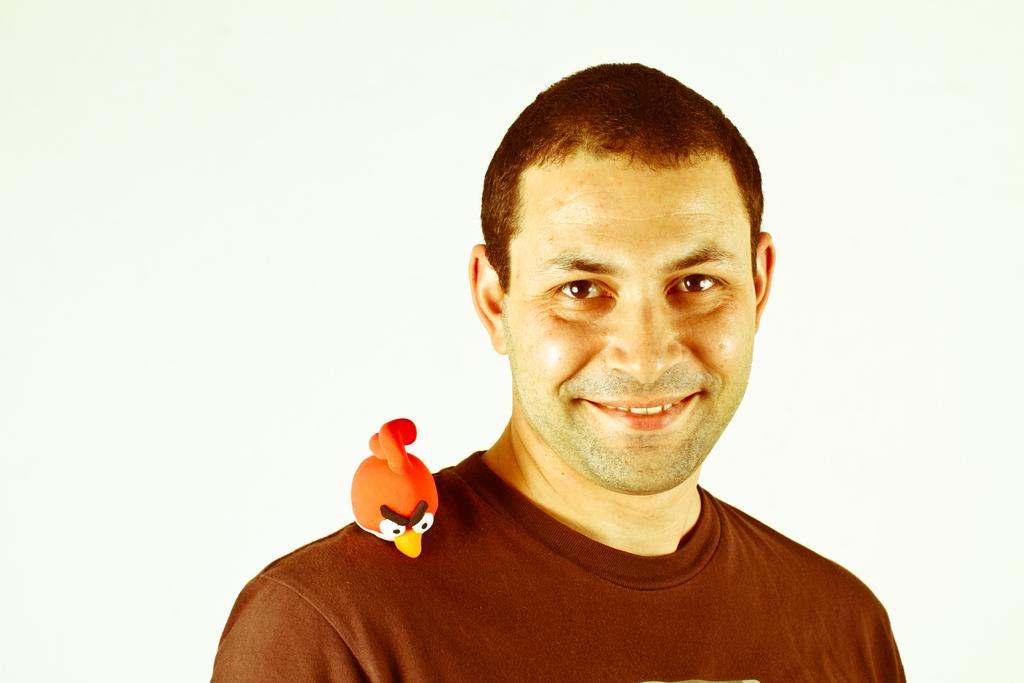What is present in the image? There is a man in the image. What is the man doing in the image? The man is smiling. What other object can be seen in the image? There is a toy in the image. What type of spacecraft can be seen in the image? There is no spacecraft present in the image. How many wings does the man have in the image? The man does not have any wings in the image. 